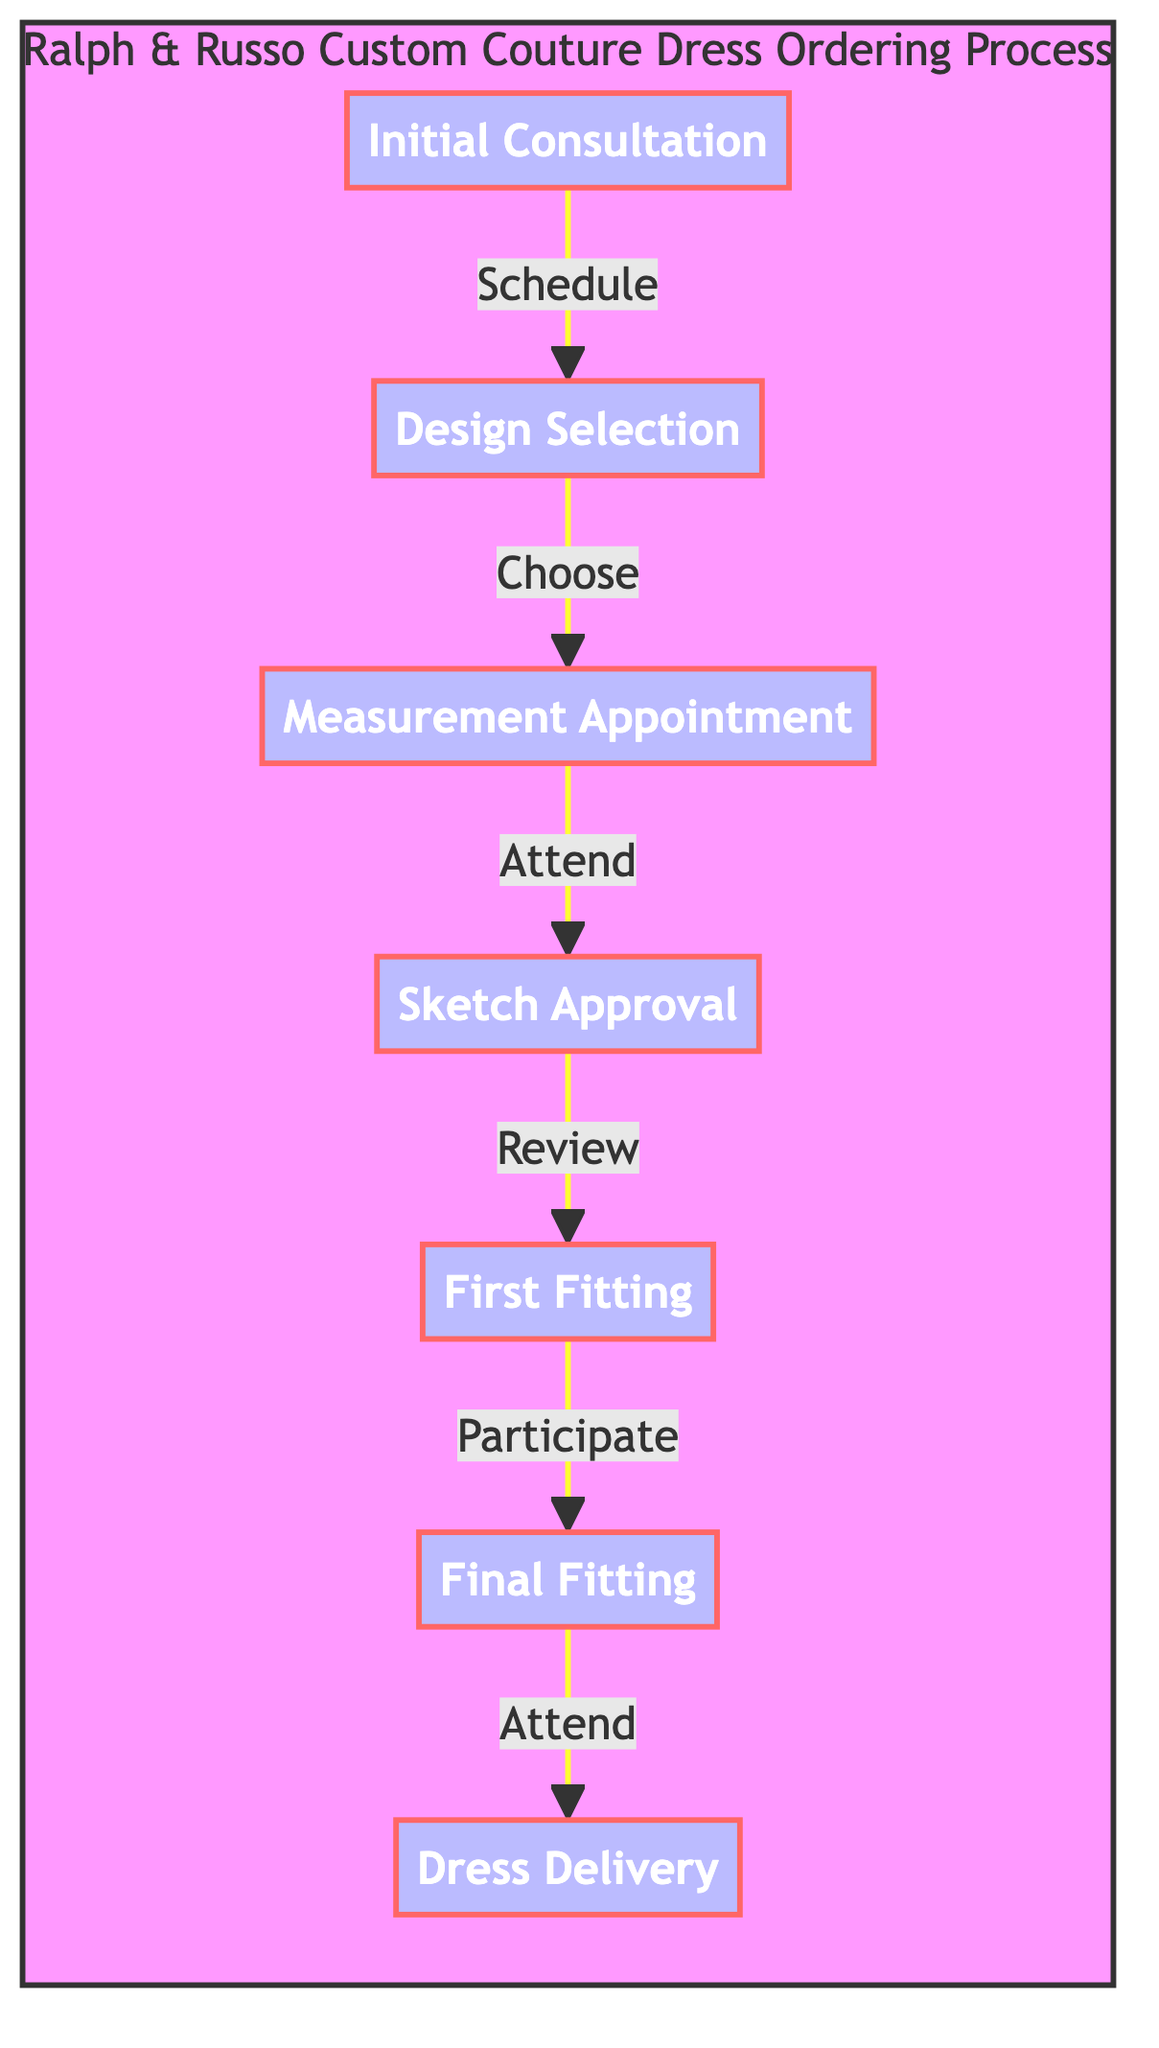What is the first step in the ordering process? The first step indicated in the diagram is the "Initial Consultation." This is the starting node where the customer schedules an appointment with a stylist.
Answer: Initial Consultation How many steps are there in the ordering process? The diagram shows a total of seven steps from "Initial Consultation" to "Dress Delivery." Each step is connected, indicating the flow of the process.
Answer: Seven What is the last step in the process? The last step in the diagram is "Dress Delivery," which is the culmination of the entire ordering process where the dress is received.
Answer: Dress Delivery What action follows the "Sketch Approval"? After "Sketch Approval," the next action in the flow is "First Fitting." This indicates that once the sketches are approved, the fitting session occurs.
Answer: First Fitting What do you do after the "Final Fitting"? After the "Final Fitting," the next action is "Dress Delivery." This denotes that once the final fitting is completed, the dress is then delivered.
Answer: Dress Delivery Which step requires you to attend a fitting session? The step that requires attending a fitting session is "Measurement Appointment." This is explicitly mentioned as a fitting session for precise measurements.
Answer: Measurement Appointment How many fitting sessions are mentioned in the process? The diagram outlines two fitting sessions: "First Fitting" and "Final Fitting." This means there are two dedicated fittings in the process.
Answer: Two What is necessary before the "First Fitting" can occur? Before the "First Fitting," a less pivotal step, which is "Sketch Approval," must occur. This shows the dependency of the fitting on the approval of the design sketches.
Answer: Sketch Approval What choice must be made after the initial consultation? After the "Initial Consultation," the next choice is "Design Selection," where the style, fabric, and embellishments are chosen.
Answer: Design Selection 